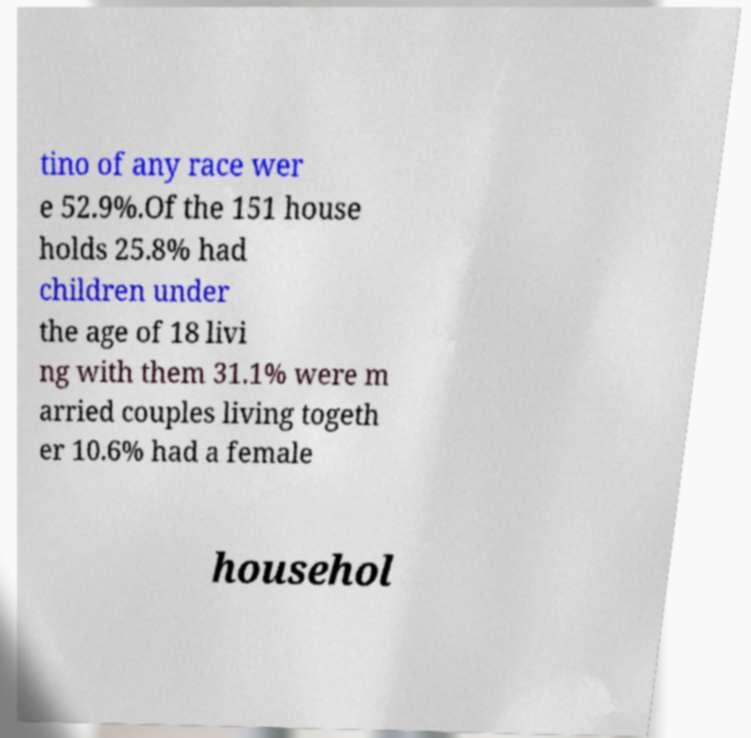Could you extract and type out the text from this image? tino of any race wer e 52.9%.Of the 151 house holds 25.8% had children under the age of 18 livi ng with them 31.1% were m arried couples living togeth er 10.6% had a female househol 